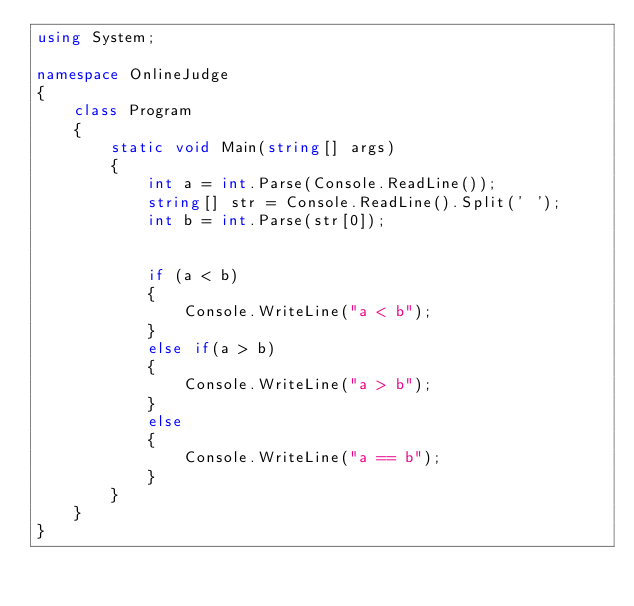<code> <loc_0><loc_0><loc_500><loc_500><_C#_>using System;

namespace OnlineJudge
{
    class Program
    {
        static void Main(string[] args)
        {
            int a = int.Parse(Console.ReadLine());
            string[] str = Console.ReadLine().Split(' ');
            int b = int.Parse(str[0]);
            

            if (a < b)
            {
                Console.WriteLine("a < b");
            }
            else if(a > b)
            {
                Console.WriteLine("a > b");
            }
            else
            {
                Console.WriteLine("a == b");
            }
        }
    }
}
</code> 